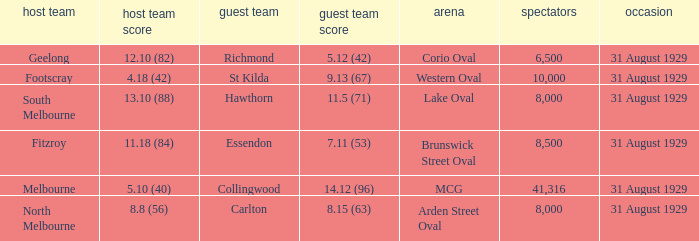What date was the game when the away team was carlton? 31 August 1929. 